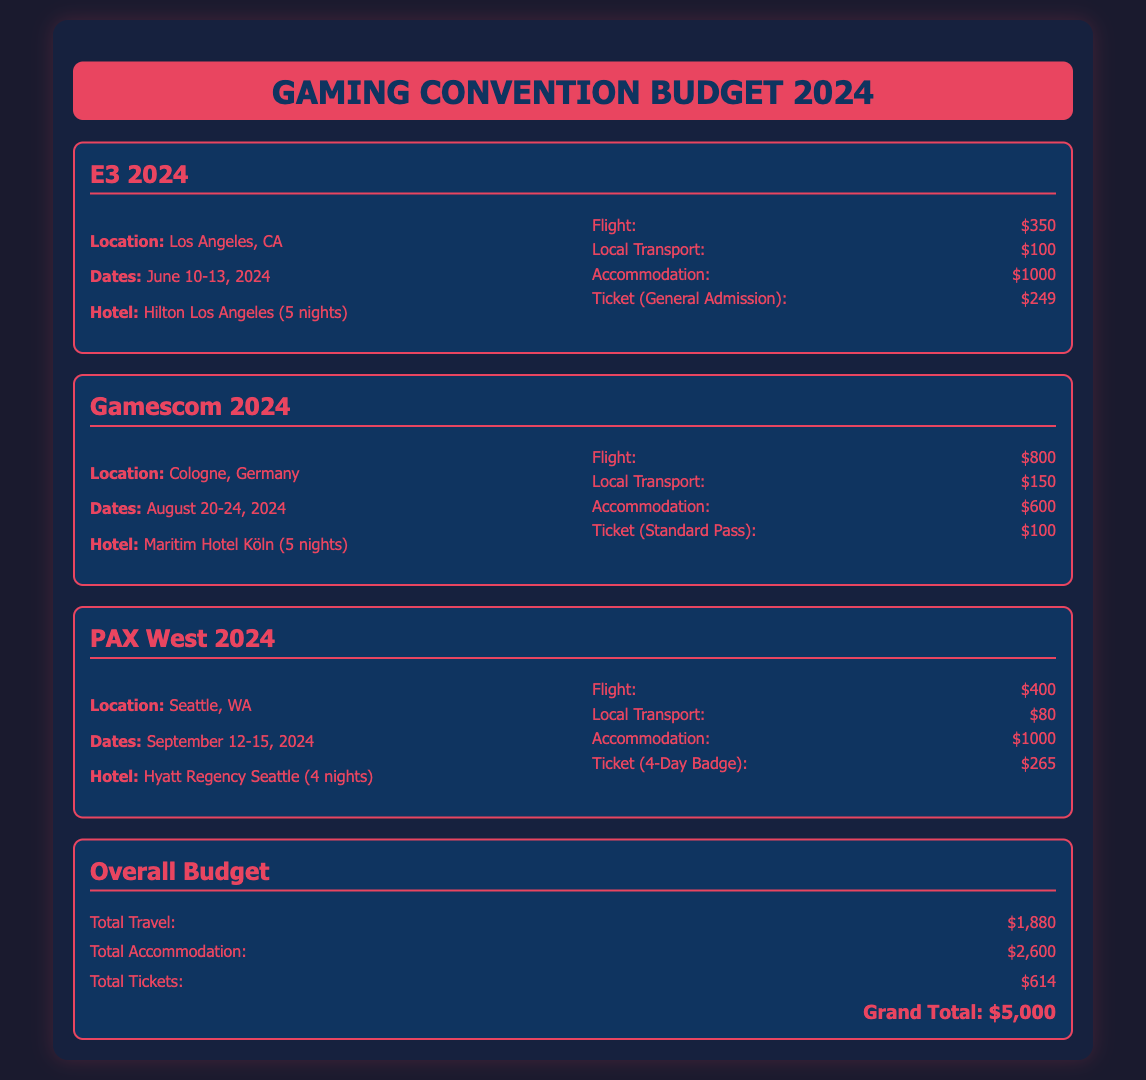What is the total budget for events in 2024? The total budget is the sum of all costs for travel, accommodation, and ticketing across the events listed, which totals $5,000.
Answer: $5,000 What are the dates for E3 2024? The event dates for E3 are explicitly stated in the document as June 10-13, 2024.
Answer: June 10-13, 2024 How much is the flight cost for Gamescom 2024? The flight cost for Gamescom is directly mentioned in the document as $800.
Answer: $800 What is the accommodation cost for PAX West 2024? The document specifies the accommodation cost for PAX West as $1,000.
Answer: $1,000 How much is the ticket for E3 2024? The cost of the general admission ticket for E3 is listed as $249 in the document.
Answer: $249 Which city will host Gamescom 2024? The location for Gamescom is stated as Cologne, Germany in the document.
Answer: Cologne, Germany What is the total transportation cost across all events? Total local transport costs of all events are summed to reach $1,250 ($100 + $150 + $80).
Answer: $1,250 How many nights is the hotel stay for E3 2024? The hotel stay for E3 is specified in the document to be for 5 nights.
Answer: 5 nights What type of ticket is available for PAX West 2024? The document refers to the ticket type for PAX West as a 4-Day Badge.
Answer: 4-Day Badge 